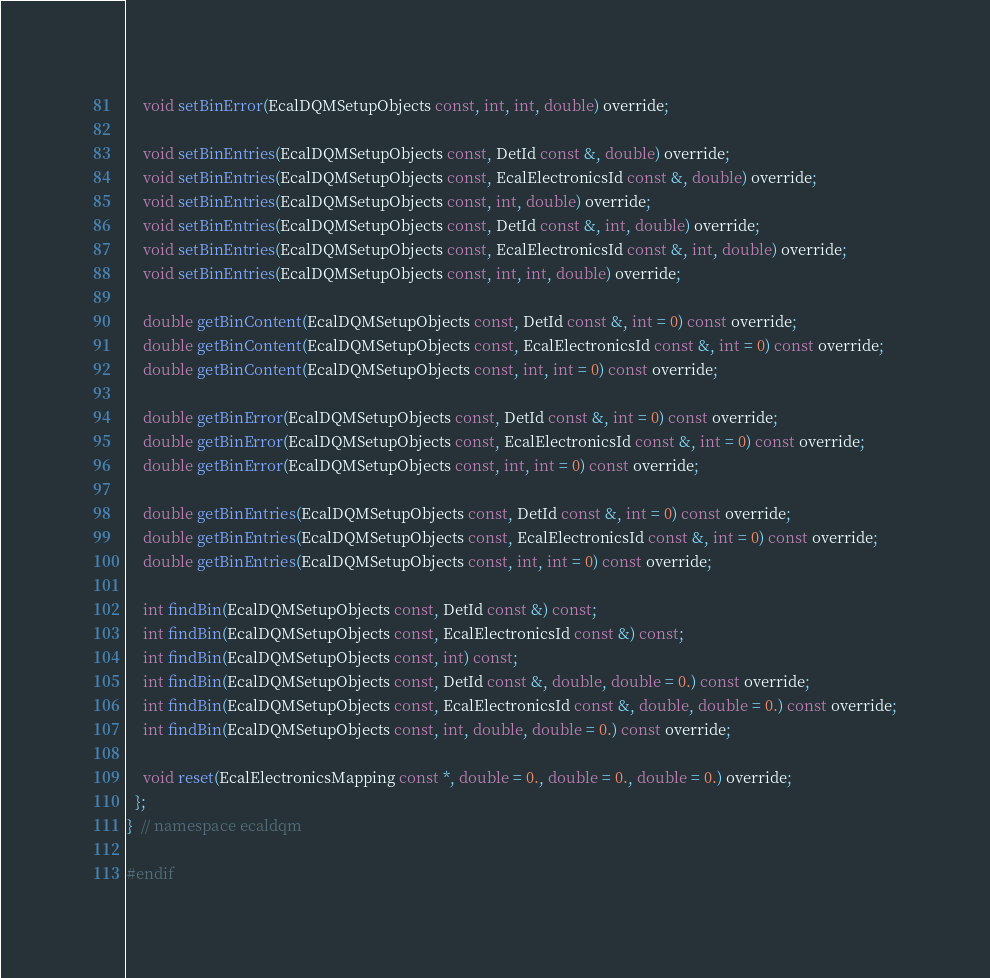Convert code to text. <code><loc_0><loc_0><loc_500><loc_500><_C_>    void setBinError(EcalDQMSetupObjects const, int, int, double) override;

    void setBinEntries(EcalDQMSetupObjects const, DetId const &, double) override;
    void setBinEntries(EcalDQMSetupObjects const, EcalElectronicsId const &, double) override;
    void setBinEntries(EcalDQMSetupObjects const, int, double) override;
    void setBinEntries(EcalDQMSetupObjects const, DetId const &, int, double) override;
    void setBinEntries(EcalDQMSetupObjects const, EcalElectronicsId const &, int, double) override;
    void setBinEntries(EcalDQMSetupObjects const, int, int, double) override;

    double getBinContent(EcalDQMSetupObjects const, DetId const &, int = 0) const override;
    double getBinContent(EcalDQMSetupObjects const, EcalElectronicsId const &, int = 0) const override;
    double getBinContent(EcalDQMSetupObjects const, int, int = 0) const override;

    double getBinError(EcalDQMSetupObjects const, DetId const &, int = 0) const override;
    double getBinError(EcalDQMSetupObjects const, EcalElectronicsId const &, int = 0) const override;
    double getBinError(EcalDQMSetupObjects const, int, int = 0) const override;

    double getBinEntries(EcalDQMSetupObjects const, DetId const &, int = 0) const override;
    double getBinEntries(EcalDQMSetupObjects const, EcalElectronicsId const &, int = 0) const override;
    double getBinEntries(EcalDQMSetupObjects const, int, int = 0) const override;

    int findBin(EcalDQMSetupObjects const, DetId const &) const;
    int findBin(EcalDQMSetupObjects const, EcalElectronicsId const &) const;
    int findBin(EcalDQMSetupObjects const, int) const;
    int findBin(EcalDQMSetupObjects const, DetId const &, double, double = 0.) const override;
    int findBin(EcalDQMSetupObjects const, EcalElectronicsId const &, double, double = 0.) const override;
    int findBin(EcalDQMSetupObjects const, int, double, double = 0.) const override;

    void reset(EcalElectronicsMapping const *, double = 0., double = 0., double = 0.) override;
  };
}  // namespace ecaldqm

#endif
</code> 